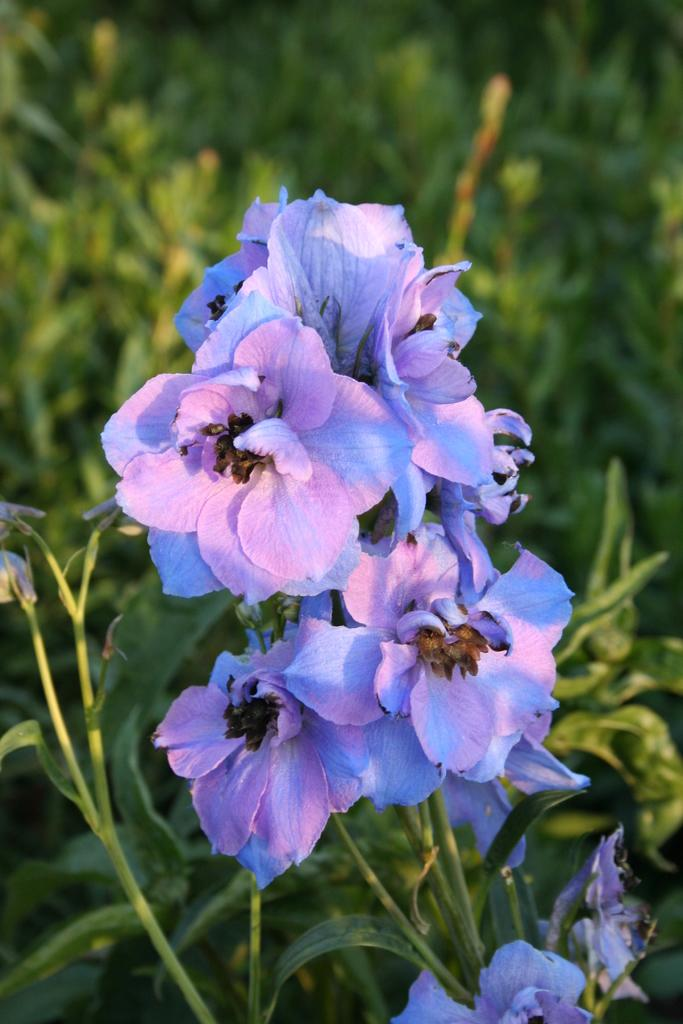What types of living organisms can be seen in the image? Plants and flowers are visible in the image. Can you describe the background of the image? The background of the image is blurred. What type of vest is the flower wearing in the image? There is no vest present in the image, as flowers do not wear clothing. 